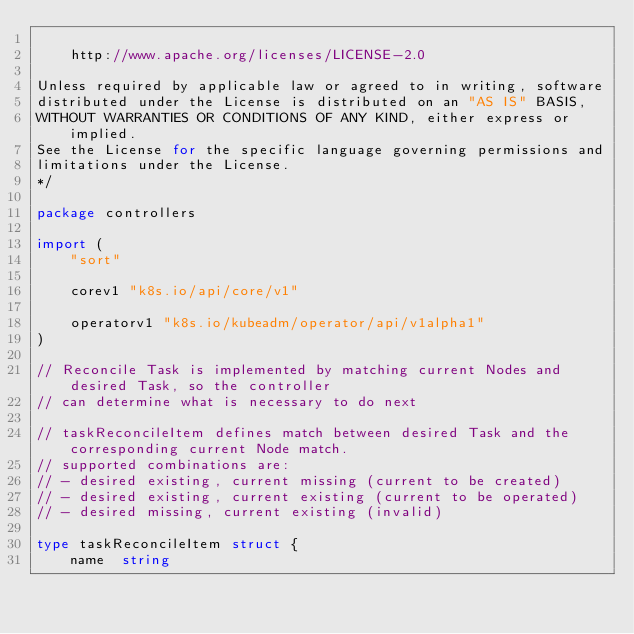<code> <loc_0><loc_0><loc_500><loc_500><_Go_>
    http://www.apache.org/licenses/LICENSE-2.0

Unless required by applicable law or agreed to in writing, software
distributed under the License is distributed on an "AS IS" BASIS,
WITHOUT WARRANTIES OR CONDITIONS OF ANY KIND, either express or implied.
See the License for the specific language governing permissions and
limitations under the License.
*/

package controllers

import (
	"sort"

	corev1 "k8s.io/api/core/v1"

	operatorv1 "k8s.io/kubeadm/operator/api/v1alpha1"
)

// Reconcile Task is implemented by matching current Nodes and desired Task, so the controller
// can determine what is necessary to do next

// taskReconcileItem defines match between desired Task and the corresponding current Node match.
// supported combinations are:
// - desired existing, current missing (current to be created)
// - desired existing, current existing (current to be operated)
// - desired missing, current existing (invalid)

type taskReconcileItem struct {
	name  string</code> 